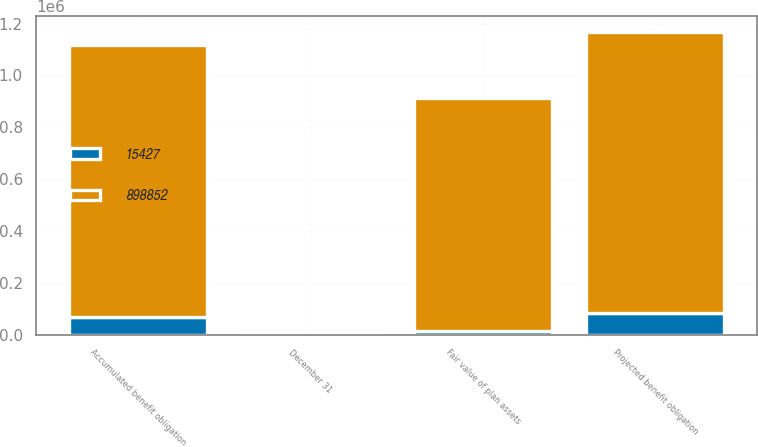Convert chart to OTSL. <chart><loc_0><loc_0><loc_500><loc_500><stacked_bar_chart><ecel><fcel>December 31<fcel>Projected benefit obligation<fcel>Accumulated benefit obligation<fcel>Fair value of plan assets<nl><fcel>898852<fcel>2011<fcel>1.08739e+06<fcel>1.049e+06<fcel>898852<nl><fcel>15427<fcel>2010<fcel>81867<fcel>69591<fcel>15427<nl></chart> 